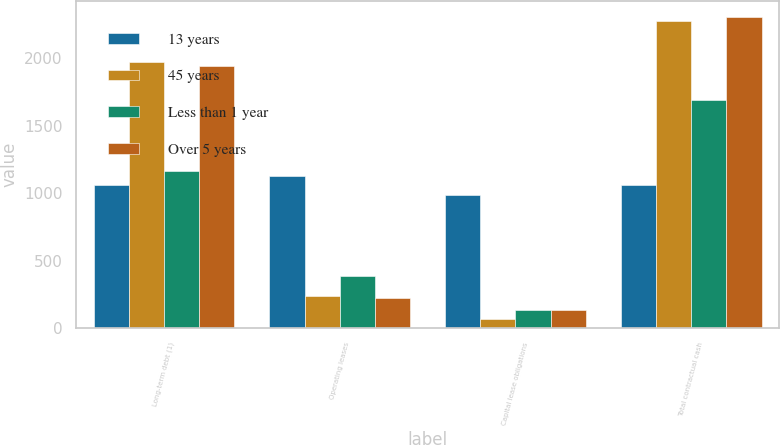Convert chart. <chart><loc_0><loc_0><loc_500><loc_500><stacked_bar_chart><ecel><fcel>Long-term debt (1)<fcel>Operating leases<fcel>Capital lease obligations<fcel>Total contractual cash<nl><fcel>13 years<fcel>1059<fcel>1129<fcel>989<fcel>1059<nl><fcel>45 years<fcel>1973<fcel>237<fcel>68<fcel>2278<nl><fcel>Less than 1 year<fcel>1169<fcel>389<fcel>136<fcel>1694<nl><fcel>Over 5 years<fcel>1944<fcel>228<fcel>138<fcel>2310<nl></chart> 